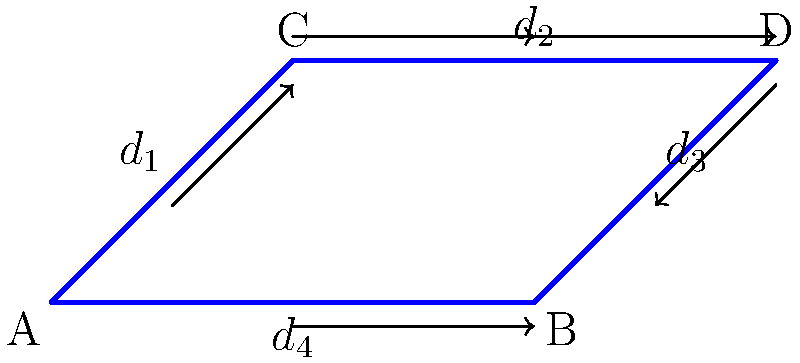In the given pipe network, water flows from point A to point B through two paths: A-C-D-B and A-B. The diameters of the pipes are $d_1$, $d_2$, $d_3$, and $d_4$ as shown in the diagram. If the flow rate in pipe $d_4$ is 20 L/s and the flow rate in pipe $d_1$ is 30 L/s, what is the flow rate in pipe $d_3$? To solve this problem, we'll use the principle of conservation of mass, which states that the total flow rate entering a junction must equal the total flow rate leaving the junction. Let's approach this step-by-step:

1. Identify the known flow rates:
   - Flow rate in pipe $d_4$ = 20 L/s
   - Flow rate in pipe $d_1$ = 30 L/s

2. Let's denote the flow rate in pipe $d_3$ as $Q_3$.

3. At point A, the total inflow must equal the total outflow:
   $Q_{in} = Q_{out}$
   $Q_{in} = Q_{d_1} + Q_{d_4}$
   $Q_{in} = 30 + 20 = 50$ L/s

4. At point B, the total inflow must also equal 50 L/s:
   $Q_{d_3} + Q_{d_4} = 50$ L/s

5. We can now solve for $Q_{d_3}$:
   $Q_{d_3} + 20 = 50$
   $Q_{d_3} = 50 - 20 = 30$ L/s

Therefore, the flow rate in pipe $d_3$ is 30 L/s.
Answer: 30 L/s 